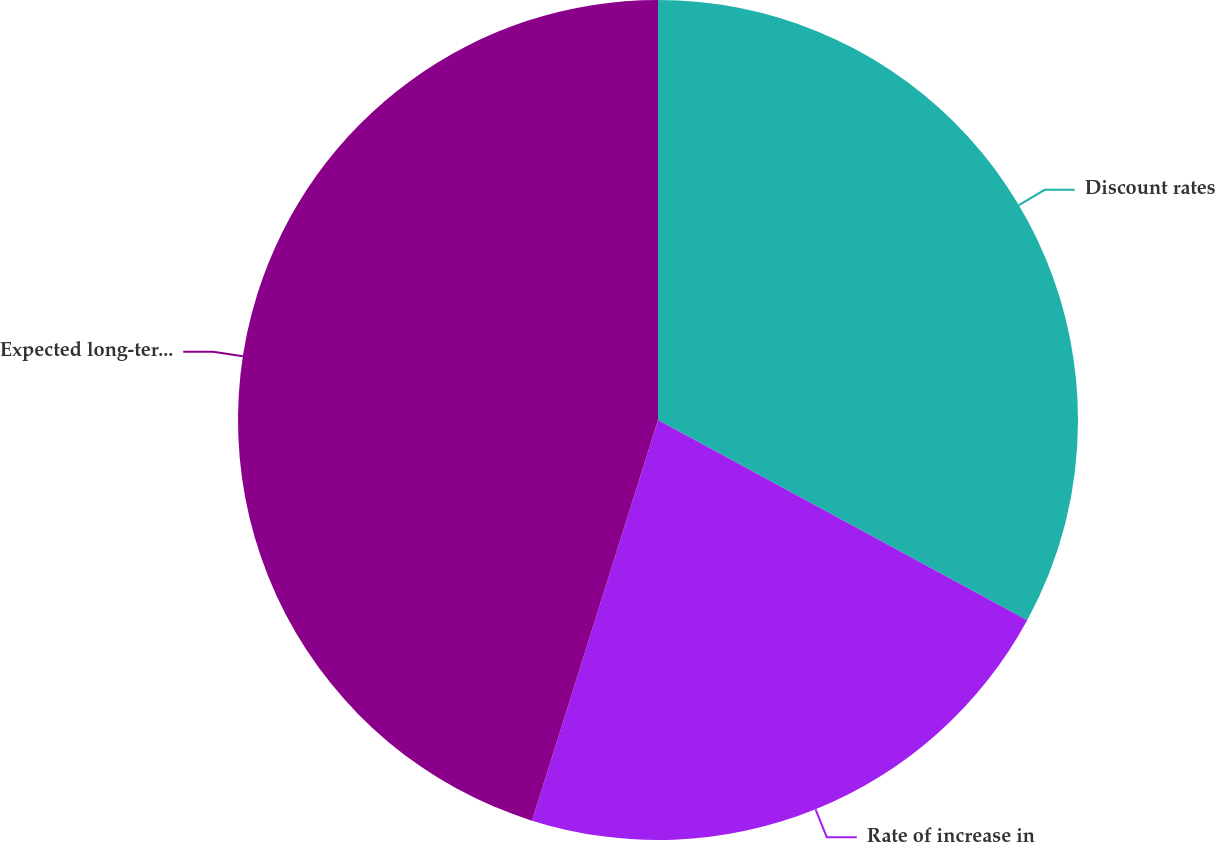<chart> <loc_0><loc_0><loc_500><loc_500><pie_chart><fcel>Discount rates<fcel>Rate of increase in<fcel>Expected long-term rate of<nl><fcel>32.91%<fcel>21.94%<fcel>45.15%<nl></chart> 